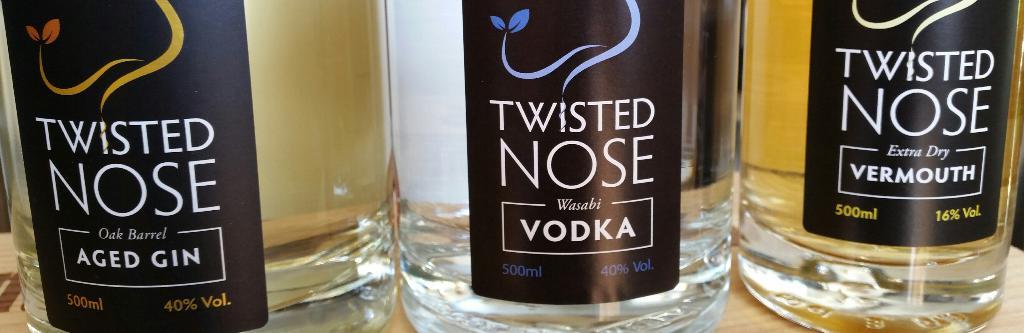What is the brand name of this vodka?
Offer a terse response. Twisted nose. 